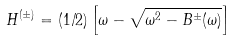Convert formula to latex. <formula><loc_0><loc_0><loc_500><loc_500>H ^ { ( \pm ) } = ( 1 / 2 ) \left [ \omega - \sqrt { \omega ^ { 2 } - B ^ { \pm } ( \omega ) } \right ]</formula> 